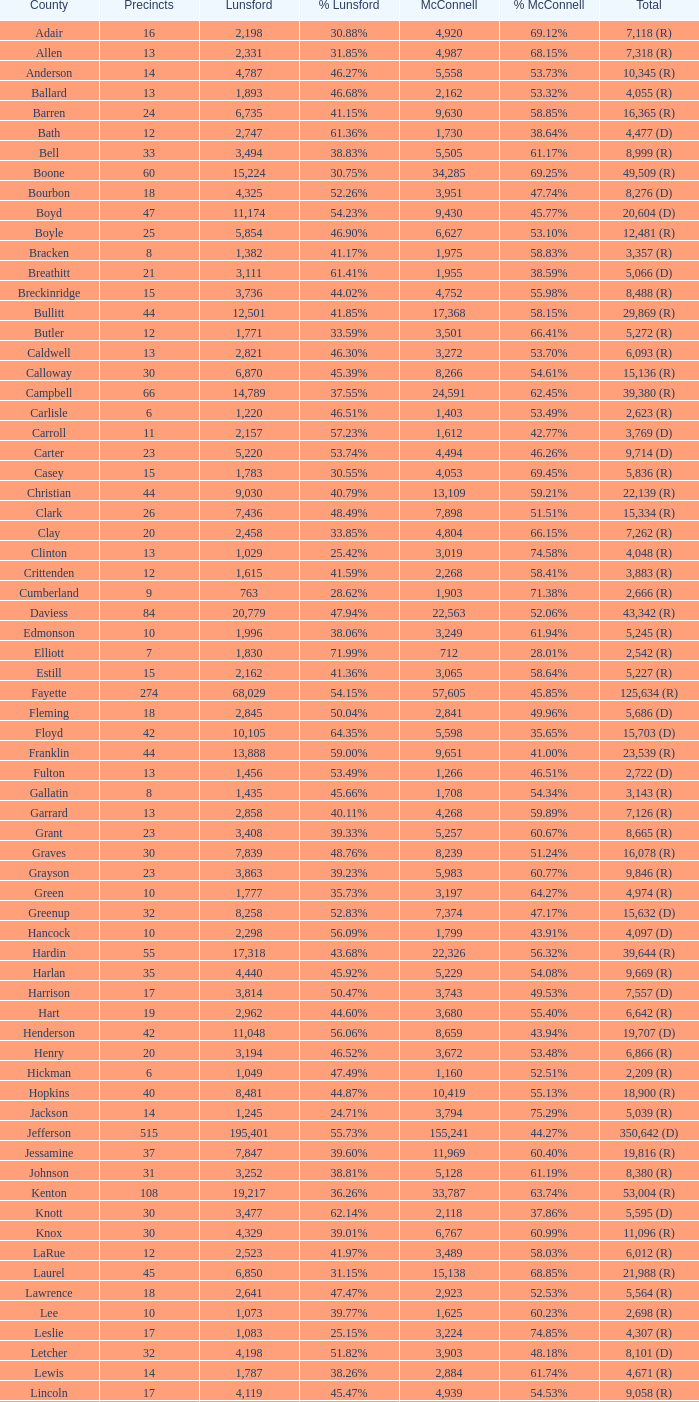What is the overall count of lunsford votes when the proportion of those votes is 3 1.0. 